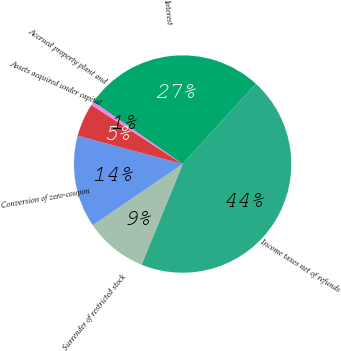Convert chart to OTSL. <chart><loc_0><loc_0><loc_500><loc_500><pie_chart><fcel>Interest<fcel>Income taxes net of refunds<fcel>Surrender of restricted stock<fcel>Conversion of zero-coupon<fcel>Assets acquired under capital<fcel>Accrued property plant and<nl><fcel>27.06%<fcel>44.39%<fcel>9.33%<fcel>13.71%<fcel>4.95%<fcel>0.56%<nl></chart> 